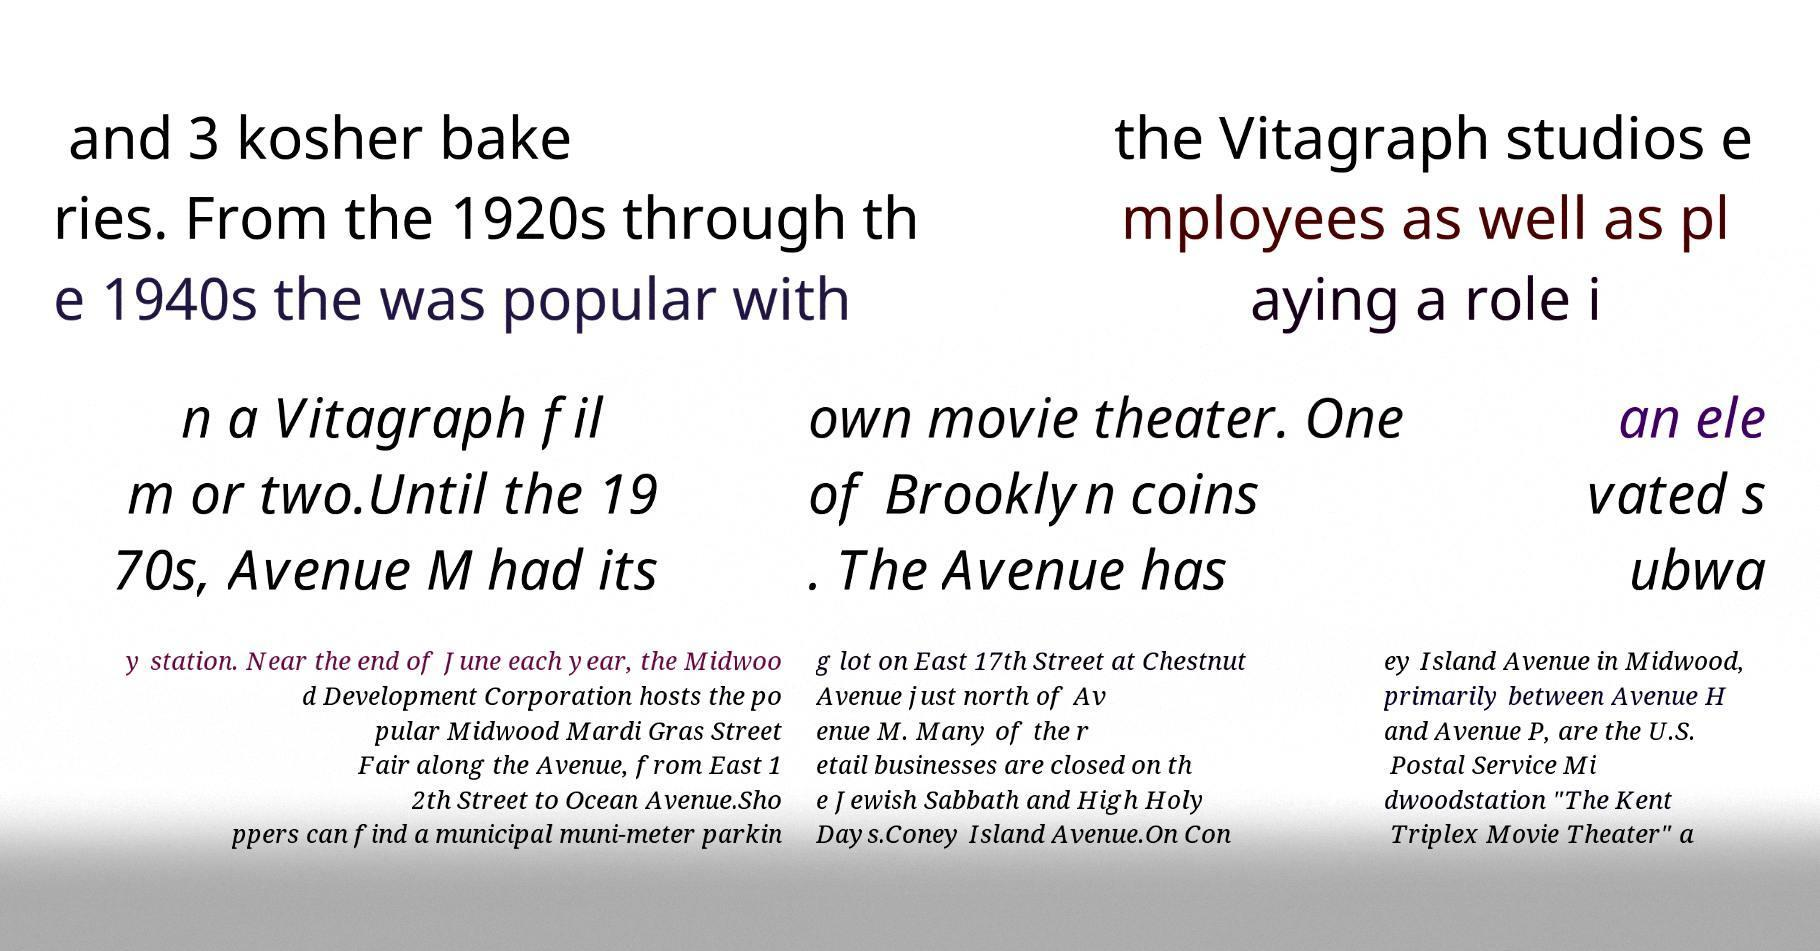Could you extract and type out the text from this image? and 3 kosher bake ries. From the 1920s through th e 1940s the was popular with the Vitagraph studios e mployees as well as pl aying a role i n a Vitagraph fil m or two.Until the 19 70s, Avenue M had its own movie theater. One of Brooklyn coins . The Avenue has an ele vated s ubwa y station. Near the end of June each year, the Midwoo d Development Corporation hosts the po pular Midwood Mardi Gras Street Fair along the Avenue, from East 1 2th Street to Ocean Avenue.Sho ppers can find a municipal muni-meter parkin g lot on East 17th Street at Chestnut Avenue just north of Av enue M. Many of the r etail businesses are closed on th e Jewish Sabbath and High Holy Days.Coney Island Avenue.On Con ey Island Avenue in Midwood, primarily between Avenue H and Avenue P, are the U.S. Postal Service Mi dwoodstation "The Kent Triplex Movie Theater" a 